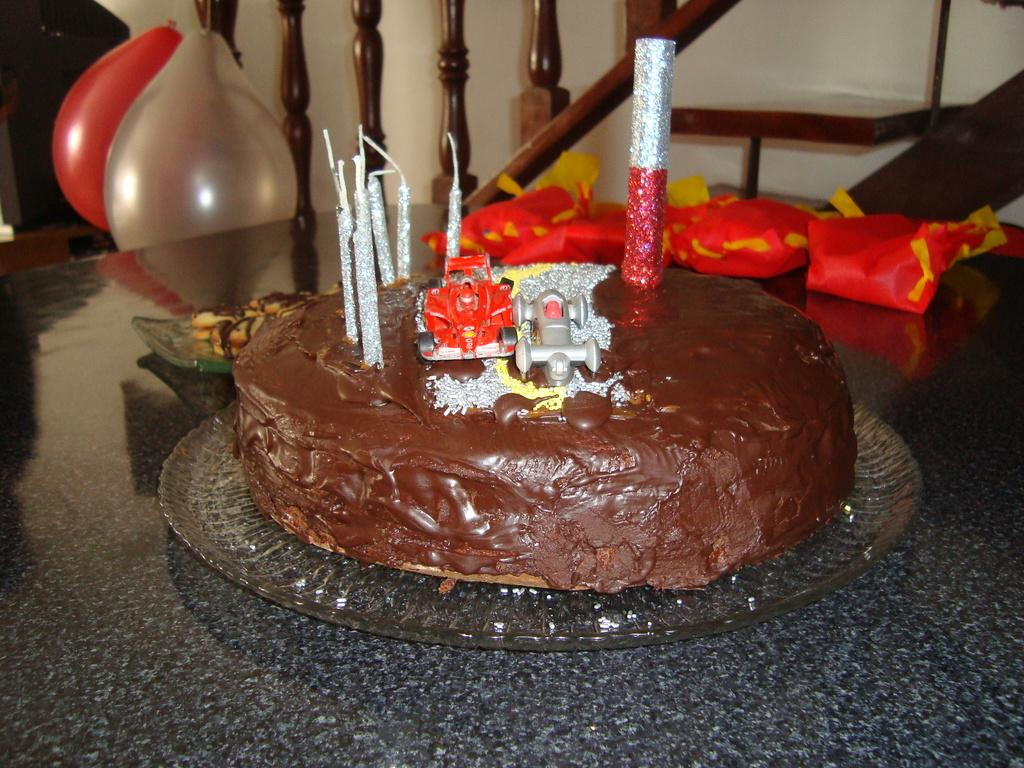What is the main piece of furniture in the image? There is a table in the image. What is placed on the table? There is a cake, trays, packets, and food on the table. What can be seen in the background of the image? There are balloons, stairs, and a wall in the background of the image. What type of property does the beginner own in the image? There is no mention of property or a beginner in the image. The image features a table with various items on it and a background with balloons, stairs, and a wall. 